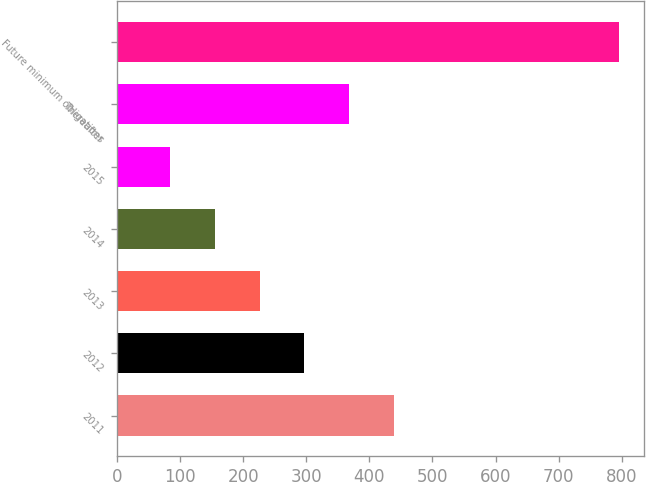Convert chart. <chart><loc_0><loc_0><loc_500><loc_500><bar_chart><fcel>2011<fcel>2012<fcel>2013<fcel>2014<fcel>2015<fcel>Thereafter<fcel>Future minimum obligations<nl><fcel>439.5<fcel>297.3<fcel>226.2<fcel>155.1<fcel>84<fcel>368.4<fcel>795<nl></chart> 